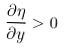Convert formula to latex. <formula><loc_0><loc_0><loc_500><loc_500>\frac { \partial \eta } { \partial y } > 0</formula> 